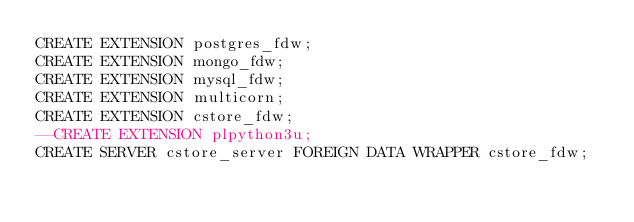<code> <loc_0><loc_0><loc_500><loc_500><_SQL_>CREATE EXTENSION postgres_fdw;
CREATE EXTENSION mongo_fdw;
CREATE EXTENSION mysql_fdw;
CREATE EXTENSION multicorn;
CREATE EXTENSION cstore_fdw;
--CREATE EXTENSION plpython3u;
CREATE SERVER cstore_server FOREIGN DATA WRAPPER cstore_fdw;
</code> 